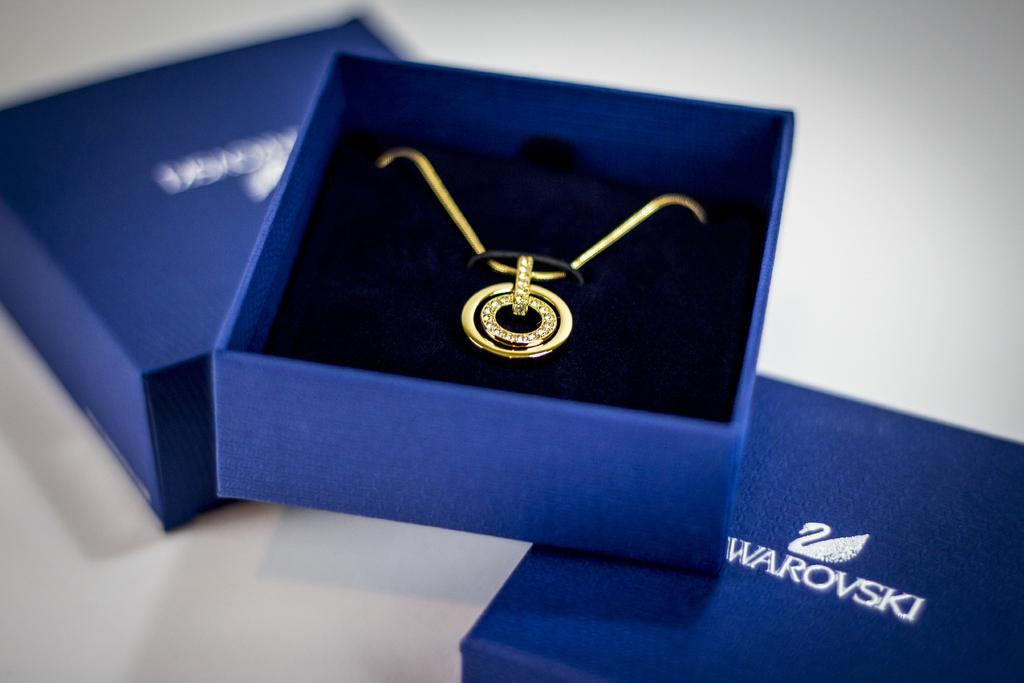<image>
Describe the image concisely. Swarovski gold necklace of two hollow circles around each other with little diamonds encrusting the entire perimeter of the inner circle. 